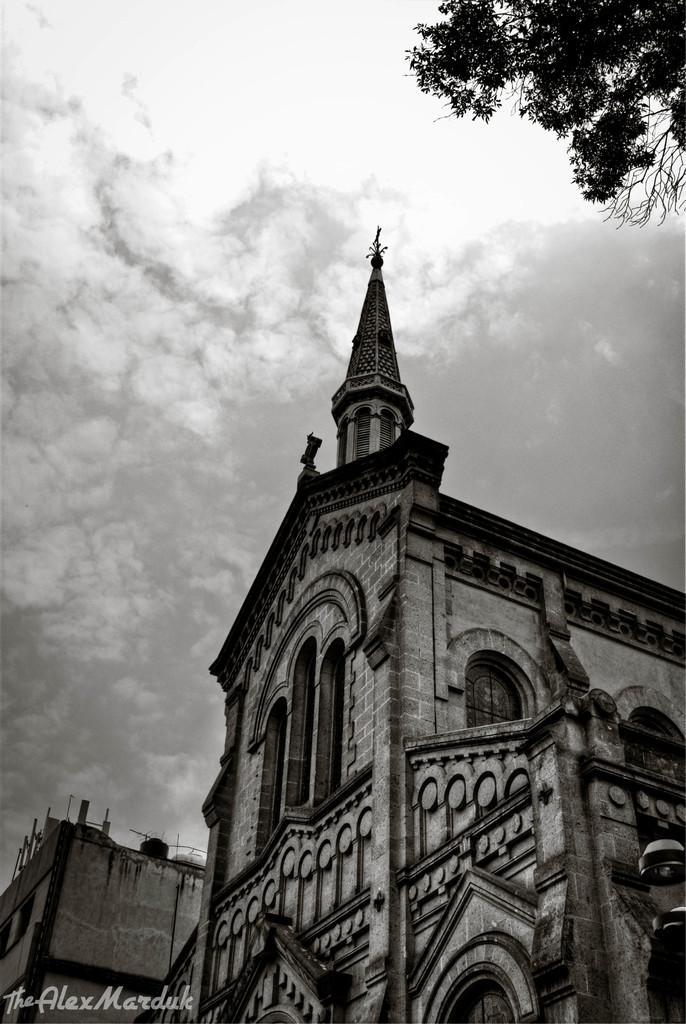Can you describe this image briefly? This is a black and white image, in this image there is a church, in the top right there is a tree, in the bottom left there is a text. 